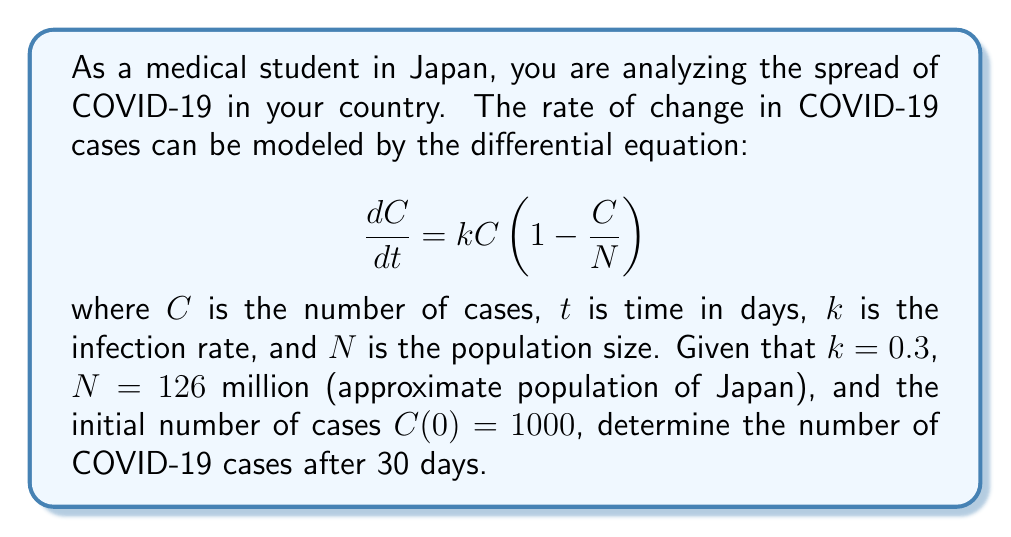Provide a solution to this math problem. To solve this problem, we need to use the given differential equation and initial conditions:

1) The differential equation is a logistic growth model:
   $$\frac{dC}{dt} = kC(1 - \frac{C}{N})$$

2) We are given:
   $k = 0.3$
   $N = 126$ million
   $C(0) = 1000$
   $t = 30$ days

3) The solution to this logistic differential equation is:
   $$C(t) = \frac{N}{1 + (\frac{N}{C_0} - 1)e^{-kt}}$$

   Where $C_0$ is the initial number of cases.

4) Substituting the given values:
   $$C(t) = \frac{126,000,000}{1 + (\frac{126,000,000}{1000} - 1)e^{-0.3t}}$$

5) For $t = 30$ days:
   $$C(30) = \frac{126,000,000}{1 + (126,000 - 1)e^{-0.3(30)}}$$

6) Calculating:
   $$C(30) = \frac{126,000,000}{1 + 125,999e^{-9}}$$
   $$C(30) = \frac{126,000,000}{1 + 125,999 * 0.0001234}$$
   $$C(30) = \frac{126,000,000}{16.55}$$
   $$C(30) \approx 7,613,293$$

Therefore, after 30 days, the number of COVID-19 cases would be approximately 7,613,293.
Answer: 7,613,293 cases 